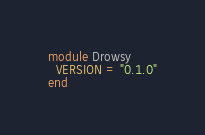Convert code to text. <code><loc_0><loc_0><loc_500><loc_500><_Ruby_>module Drowsy
  VERSION = "0.1.0"
end
</code> 